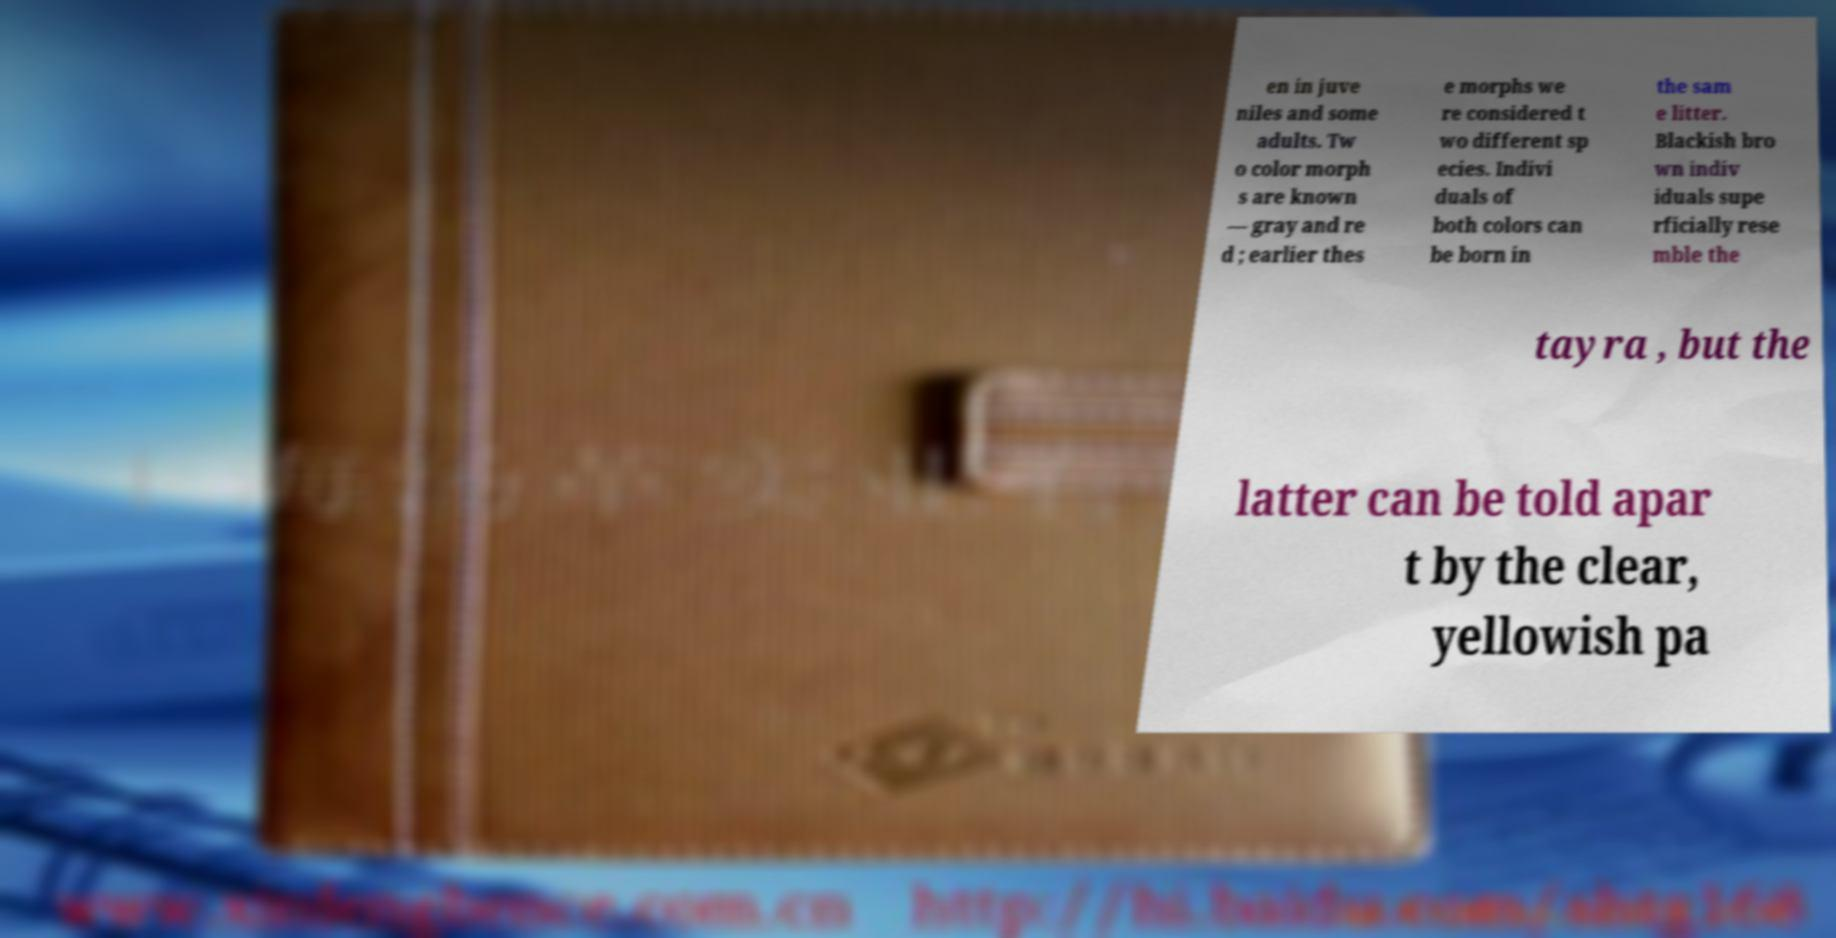Please read and relay the text visible in this image. What does it say? en in juve niles and some adults. Tw o color morph s are known — gray and re d ; earlier thes e morphs we re considered t wo different sp ecies. Indivi duals of both colors can be born in the sam e litter. Blackish bro wn indiv iduals supe rficially rese mble the tayra , but the latter can be told apar t by the clear, yellowish pa 